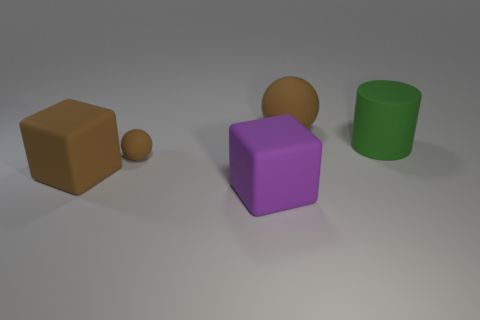What number of brown things are big matte spheres or big matte cylinders?
Make the answer very short. 1. What number of small spheres are the same color as the large matte ball?
Your answer should be compact. 1. What number of big things are right of the large brown matte object that is to the left of the big ball?
Make the answer very short. 3. What number of brown things are the same material as the big cylinder?
Keep it short and to the point. 3. Does the big brown rubber object that is right of the brown block have the same shape as the tiny object?
Provide a succinct answer. Yes. What shape is the big brown matte object that is on the right side of the brown rubber sphere in front of the cylinder?
Your answer should be compact. Sphere. Is there anything else that has the same shape as the green thing?
Offer a terse response. No. There is another matte thing that is the same shape as the purple object; what is its color?
Give a very brief answer. Brown. Do the large sphere and the tiny matte ball on the right side of the large brown matte cube have the same color?
Make the answer very short. Yes. What shape is the large thing that is both in front of the big rubber cylinder and right of the brown block?
Your answer should be very brief. Cube. 